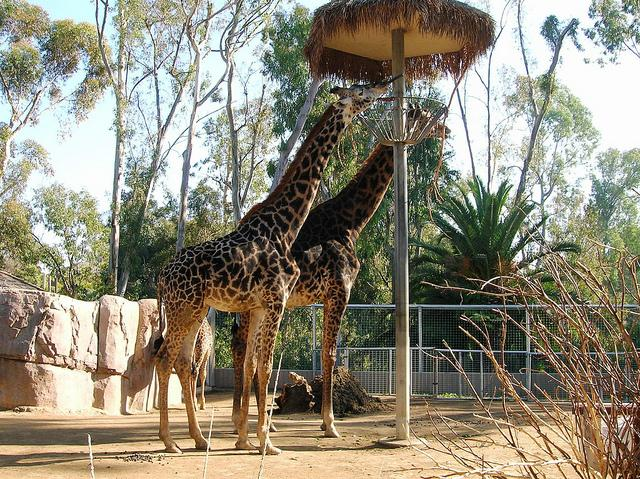What kind of fencing encloses these giraffes in the zoo? metal 